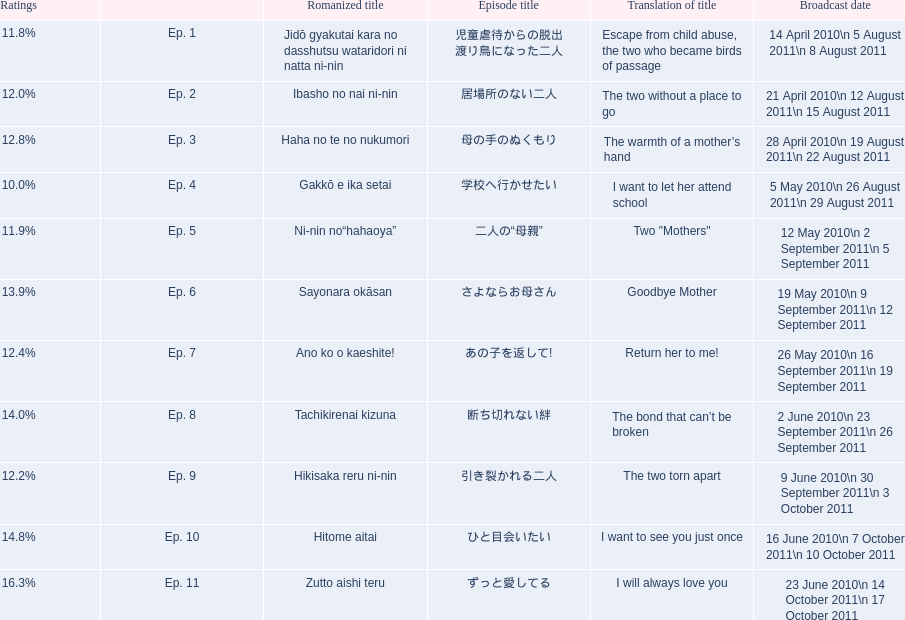What are the episode numbers? Ep. 1, Ep. 2, Ep. 3, Ep. 4, Ep. 5, Ep. 6, Ep. 7, Ep. 8, Ep. 9, Ep. 10, Ep. 11. Could you parse the entire table? {'header': ['Ratings', '', 'Romanized title', 'Episode title', 'Translation of title', 'Broadcast date'], 'rows': [['11.8%', 'Ep. 1', 'Jidō gyakutai kara no dasshutsu wataridori ni natta ni-nin', '児童虐待からの脱出 渡り鳥になった二人', 'Escape from child abuse, the two who became birds of passage', '14 April 2010\\n 5 August 2011\\n 8 August 2011'], ['12.0%', 'Ep. 2', 'Ibasho no nai ni-nin', '居場所のない二人', 'The two without a place to go', '21 April 2010\\n 12 August 2011\\n 15 August 2011'], ['12.8%', 'Ep. 3', 'Haha no te no nukumori', '母の手のぬくもり', 'The warmth of a mother’s hand', '28 April 2010\\n 19 August 2011\\n 22 August 2011'], ['10.0%', 'Ep. 4', 'Gakkō e ika setai', '学校へ行かせたい', 'I want to let her attend school', '5 May 2010\\n 26 August 2011\\n 29 August 2011'], ['11.9%', 'Ep. 5', 'Ni-nin no“hahaoya”', '二人の“母親”', 'Two "Mothers"', '12 May 2010\\n 2 September 2011\\n 5 September 2011'], ['13.9%', 'Ep. 6', 'Sayonara okāsan', 'さよならお母さん', 'Goodbye Mother', '19 May 2010\\n 9 September 2011\\n 12 September 2011'], ['12.4%', 'Ep. 7', 'Ano ko o kaeshite!', 'あの子を返して!', 'Return her to me!', '26 May 2010\\n 16 September 2011\\n 19 September 2011'], ['14.0%', 'Ep. 8', 'Tachikirenai kizuna', '断ち切れない絆', 'The bond that can’t be broken', '2 June 2010\\n 23 September 2011\\n 26 September 2011'], ['12.2%', 'Ep. 9', 'Hikisaka reru ni-nin', '引き裂かれる二人', 'The two torn apart', '9 June 2010\\n 30 September 2011\\n 3 October 2011'], ['14.8%', 'Ep. 10', 'Hitome aitai', 'ひと目会いたい', 'I want to see you just once', '16 June 2010\\n 7 October 2011\\n 10 October 2011'], ['16.3%', 'Ep. 11', 'Zutto aishi teru', 'ずっと愛してる', 'I will always love you', '23 June 2010\\n 14 October 2011\\n 17 October 2011']]} What was the percentage of total ratings for episode 8? 14.0%. 